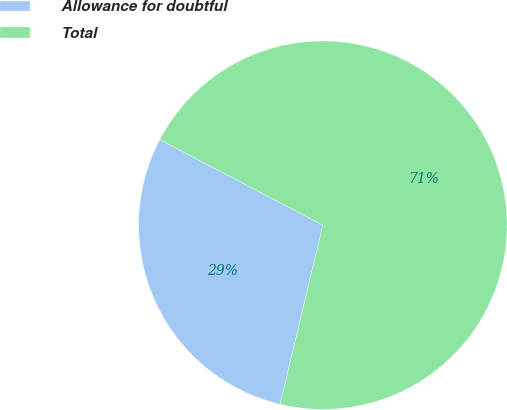<chart> <loc_0><loc_0><loc_500><loc_500><pie_chart><fcel>Allowance for doubtful<fcel>Total<nl><fcel>28.96%<fcel>71.04%<nl></chart> 